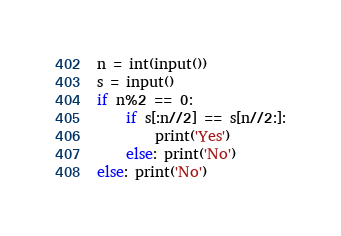<code> <loc_0><loc_0><loc_500><loc_500><_Python_>n = int(input())
s = input()
if n%2 == 0:
    if s[:n//2] == s[n//2:]:
        print('Yes')
    else: print('No')
else: print('No')</code> 